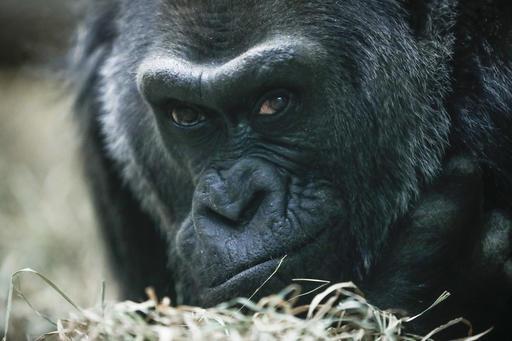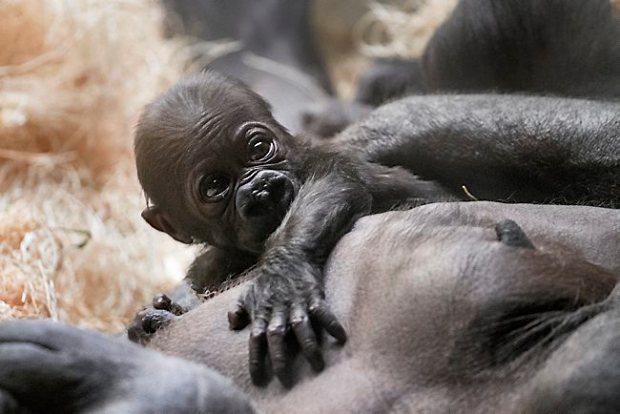The first image is the image on the left, the second image is the image on the right. Analyze the images presented: Is the assertion "A baby gorilla is clinging to the chest of an adult gorilla in one image, and the other image includes at least one baby gorilla in a different position [than the aforementioned image]." valid? Answer yes or no. No. The first image is the image on the left, the second image is the image on the right. Examine the images to the left and right. Is the description "A baby primate lies on an adult in each of the images." accurate? Answer yes or no. No. 